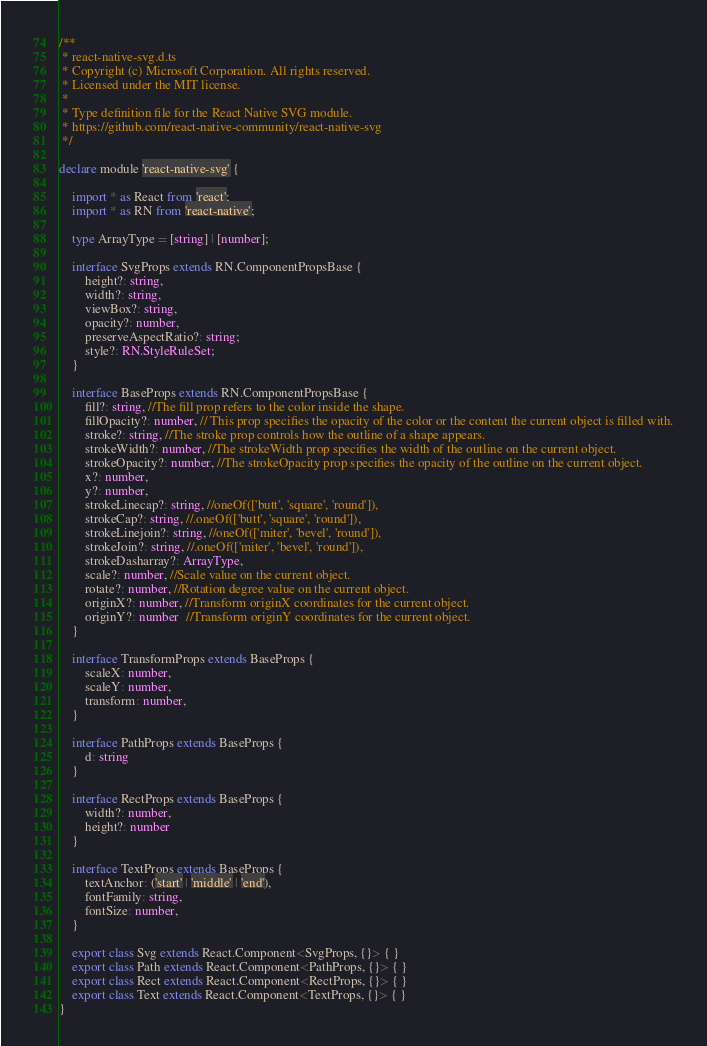Convert code to text. <code><loc_0><loc_0><loc_500><loc_500><_TypeScript_>/**
 * react-native-svg.d.ts
 * Copyright (c) Microsoft Corporation. All rights reserved.
 * Licensed under the MIT license.
 *
 * Type definition file for the React Native SVG module.
 * https://github.com/react-native-community/react-native-svg
 */

declare module 'react-native-svg' {

    import * as React from 'react';
    import * as RN from 'react-native';

    type ArrayType = [string] | [number];

    interface SvgProps extends RN.ComponentPropsBase {
        height?: string,
        width?: string,
        viewBox?: string,
        opacity?: number,
        preserveAspectRatio?: string;
        style?: RN.StyleRuleSet;
    }

    interface BaseProps extends RN.ComponentPropsBase {
        fill?: string, //The fill prop refers to the color inside the shape.
        fillOpacity?: number, // This prop specifies the opacity of the color or the content the current object is filled with.
        stroke?: string, //The stroke prop controls how the outline of a shape appears.
        strokeWidth?: number, //The strokeWidth prop specifies the width of the outline on the current object.
        strokeOpacity?: number, //The strokeOpacity prop specifies the opacity of the outline on the current object.
        x?: number,
        y?: number,
        strokeLinecap?: string, //oneOf(['butt', 'square', 'round']),
        strokeCap?: string, //.oneOf(['butt', 'square', 'round']),
        strokeLinejoin?: string, //oneOf(['miter', 'bevel', 'round']),
        strokeJoin?: string, //.oneOf(['miter', 'bevel', 'round']),
        strokeDasharray?: ArrayType,
        scale?: number, //Scale value on the current object.
        rotate?: number, //Rotation degree value on the current object.
        originX?: number, //Transform originX coordinates for the current object.
        originY?: number  //Transform originY coordinates for the current object.
    }

    interface TransformProps extends BaseProps {
        scaleX: number,
        scaleY: number,
        transform: number,
    }

    interface PathProps extends BaseProps {
        d: string
    }

    interface RectProps extends BaseProps {
        width?: number,
        height?: number
    }

    interface TextProps extends BaseProps {
        textAnchor: ('start' | 'middle' | 'end'),
        fontFamily: string,
        fontSize: number,
    }

    export class Svg extends React.Component<SvgProps, {}> { }
    export class Path extends React.Component<PathProps, {}> { }
    export class Rect extends React.Component<RectProps, {}> { }
    export class Text extends React.Component<TextProps, {}> { }
}
</code> 